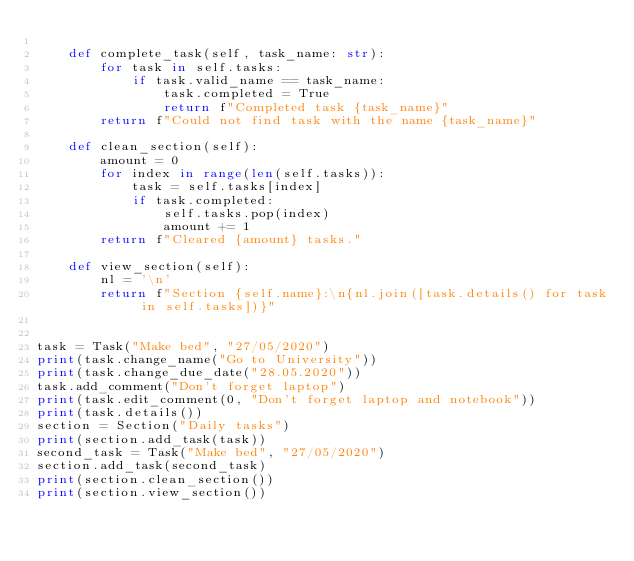Convert code to text. <code><loc_0><loc_0><loc_500><loc_500><_Python_>
    def complete_task(self, task_name: str):
        for task in self.tasks:
            if task.valid_name == task_name:
                task.completed = True
                return f"Completed task {task_name}"
        return f"Could not find task with the name {task_name}"

    def clean_section(self):
        amount = 0
        for index in range(len(self.tasks)):
            task = self.tasks[index]
            if task.completed:
                self.tasks.pop(index)
                amount += 1
        return f"Cleared {amount} tasks."

    def view_section(self):
        nl = '\n'
        return f"Section {self.name}:\n{nl.join([task.details() for task in self.tasks])}"


task = Task("Make bed", "27/05/2020")
print(task.change_name("Go to University"))
print(task.change_due_date("28.05.2020"))
task.add_comment("Don't forget laptop")
print(task.edit_comment(0, "Don't forget laptop and notebook"))
print(task.details())
section = Section("Daily tasks")
print(section.add_task(task))
second_task = Task("Make bed", "27/05/2020")
section.add_task(second_task)
print(section.clean_section())
print(section.view_section())
</code> 